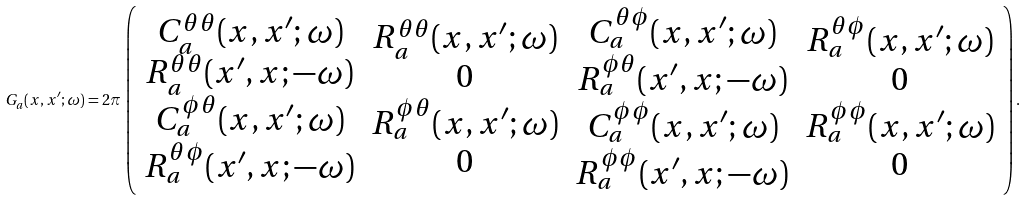<formula> <loc_0><loc_0><loc_500><loc_500>G _ { a } ( x , x ^ { \prime } ; \omega ) = 2 \pi \, \left ( \begin{array} { c } C _ { a } ^ { \theta \theta } ( x , x ^ { \prime } ; \omega ) \\ R _ { a } ^ { \theta \theta } ( x ^ { \prime } , x ; - \omega ) \\ C _ { a } ^ { \phi \theta } ( x , x ^ { \prime } ; \omega ) \\ R _ { a } ^ { \theta \phi } ( x ^ { \prime } , x ; - \omega ) \end{array} \begin{array} { c } R _ { a } ^ { \theta \theta } ( x , x ^ { \prime } ; \omega ) \\ 0 \\ R _ { a } ^ { \phi \theta } ( x , x ^ { \prime } ; \omega ) \\ 0 \end{array} \begin{array} { c } C _ { a } ^ { \theta \phi } ( x , x ^ { \prime } ; \omega ) \\ R _ { a } ^ { \phi \theta } ( x ^ { \prime } , x ; - \omega ) \\ C _ { a } ^ { \phi \phi } ( x , x ^ { \prime } ; \omega ) \\ R _ { a } ^ { \phi \phi } ( x ^ { \prime } , x ; - \omega ) \end{array} \begin{array} { c } R _ { a } ^ { \theta \phi } ( x , x ^ { \prime } ; \omega ) \\ 0 \\ R _ { a } ^ { \phi \phi } ( x , x ^ { \prime } ; \omega ) \\ 0 \end{array} \right ) .</formula> 